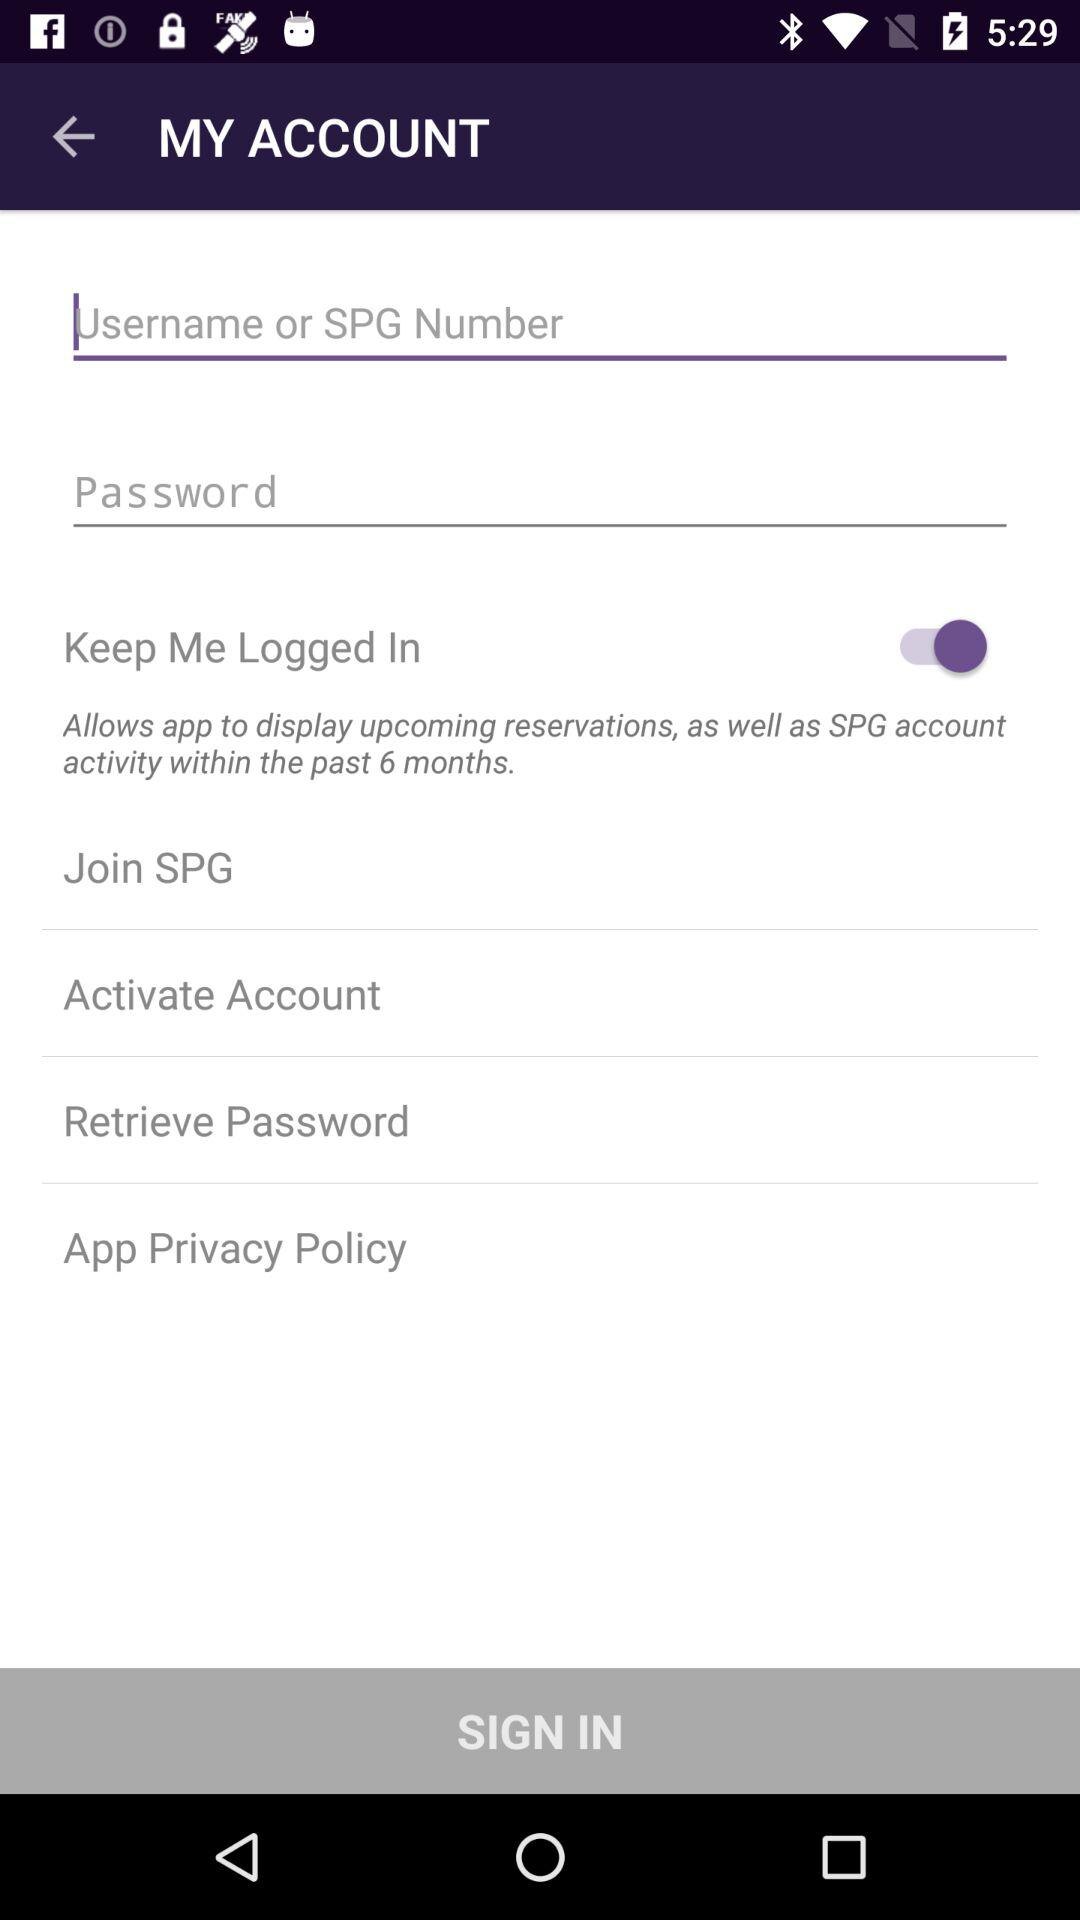How many text inputs are there for logging in?
Answer the question using a single word or phrase. 2 